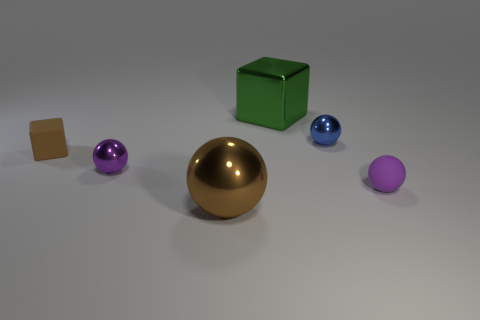Add 4 purple matte things. How many objects exist? 10 Subtract all blocks. How many objects are left? 4 Add 2 small blue shiny spheres. How many small blue shiny spheres are left? 3 Add 6 tiny brown cubes. How many tiny brown cubes exist? 7 Subtract 0 yellow cubes. How many objects are left? 6 Subtract all purple blocks. Subtract all metal cubes. How many objects are left? 5 